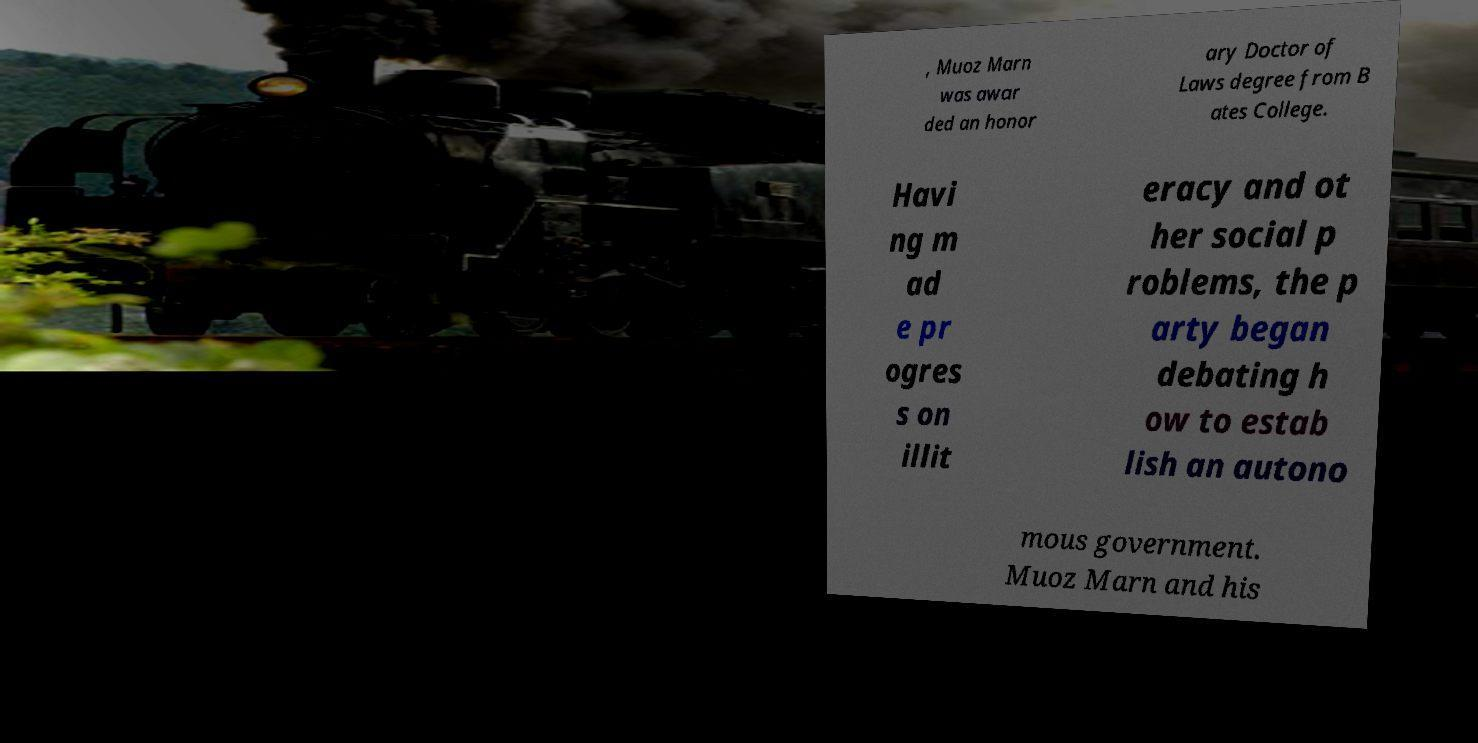For documentation purposes, I need the text within this image transcribed. Could you provide that? , Muoz Marn was awar ded an honor ary Doctor of Laws degree from B ates College. Havi ng m ad e pr ogres s on illit eracy and ot her social p roblems, the p arty began debating h ow to estab lish an autono mous government. Muoz Marn and his 